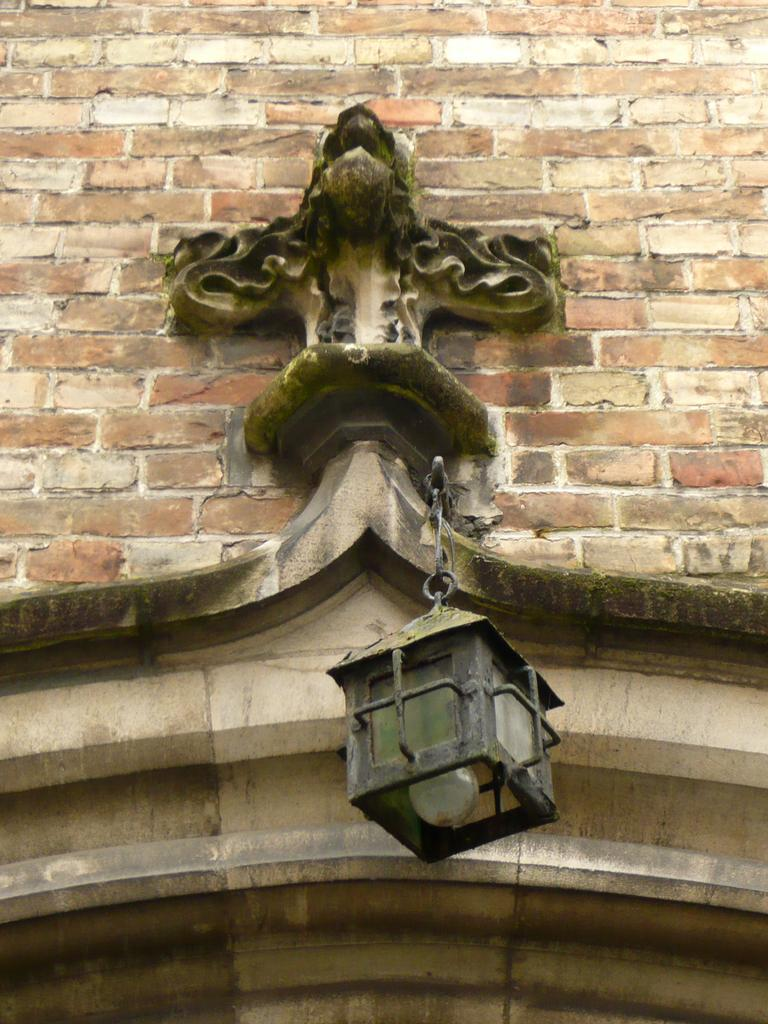What is the main object in the image? There is a light in the image. How is the light positioned in the image? The light is hanging from a pole. Is the pole connected to any structure in the image? Yes, the pole is attached to a wall. What type of insect is crawling on the light in the image? There are no insects present in the image; it only features a light hanging from a pole attached to a wall. 